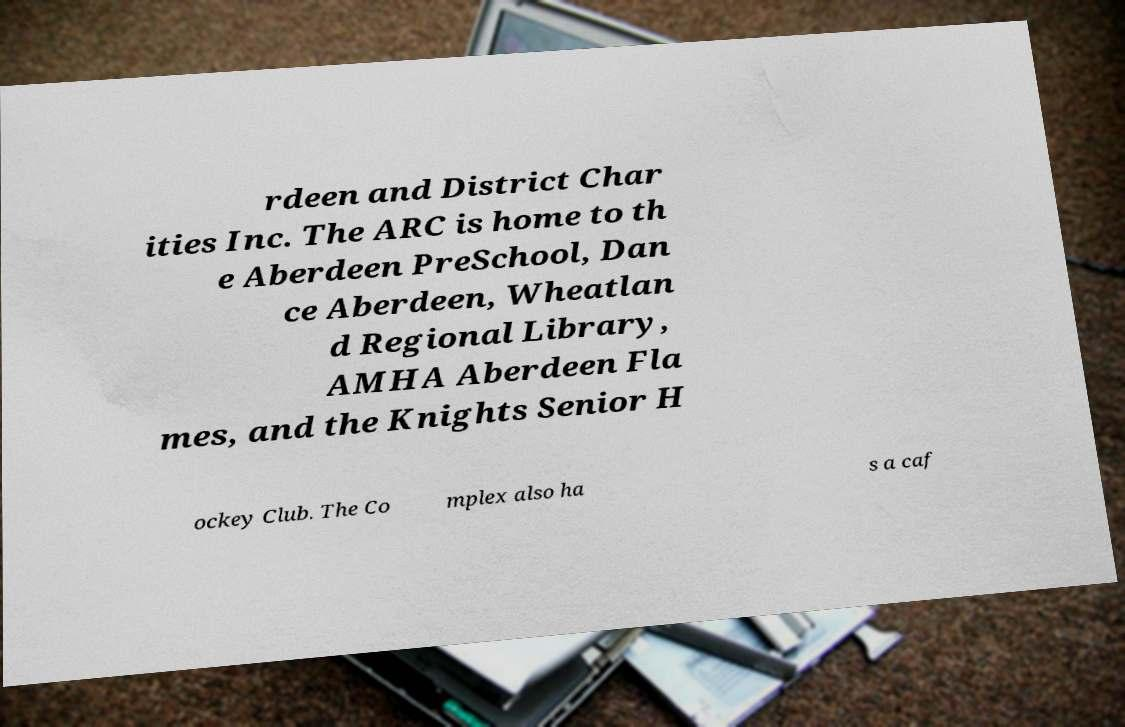I need the written content from this picture converted into text. Can you do that? rdeen and District Char ities Inc. The ARC is home to th e Aberdeen PreSchool, Dan ce Aberdeen, Wheatlan d Regional Library, AMHA Aberdeen Fla mes, and the Knights Senior H ockey Club. The Co mplex also ha s a caf 